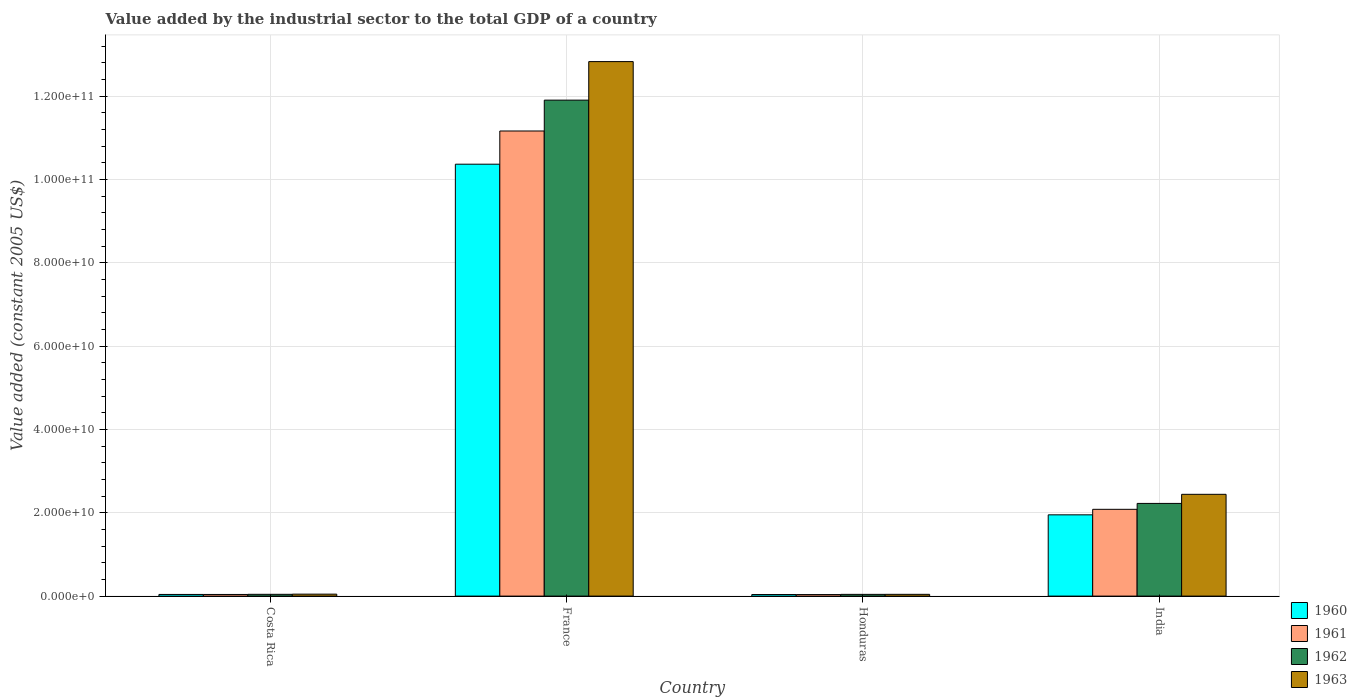How many groups of bars are there?
Provide a short and direct response. 4. Are the number of bars per tick equal to the number of legend labels?
Provide a succinct answer. Yes. How many bars are there on the 3rd tick from the right?
Provide a succinct answer. 4. What is the label of the 3rd group of bars from the left?
Your response must be concise. Honduras. In how many cases, is the number of bars for a given country not equal to the number of legend labels?
Your response must be concise. 0. What is the value added by the industrial sector in 1962 in Costa Rica?
Your answer should be very brief. 4.27e+08. Across all countries, what is the maximum value added by the industrial sector in 1960?
Keep it short and to the point. 1.04e+11. Across all countries, what is the minimum value added by the industrial sector in 1960?
Keep it short and to the point. 3.75e+08. In which country was the value added by the industrial sector in 1961 maximum?
Provide a short and direct response. France. In which country was the value added by the industrial sector in 1962 minimum?
Your response must be concise. Honduras. What is the total value added by the industrial sector in 1960 in the graph?
Ensure brevity in your answer.  1.24e+11. What is the difference between the value added by the industrial sector in 1961 in Costa Rica and that in India?
Offer a terse response. -2.04e+1. What is the difference between the value added by the industrial sector in 1962 in France and the value added by the industrial sector in 1961 in Costa Rica?
Provide a short and direct response. 1.19e+11. What is the average value added by the industrial sector in 1961 per country?
Your response must be concise. 3.33e+1. What is the difference between the value added by the industrial sector of/in 1960 and value added by the industrial sector of/in 1963 in India?
Your response must be concise. -4.92e+09. In how many countries, is the value added by the industrial sector in 1963 greater than 48000000000 US$?
Offer a very short reply. 1. What is the ratio of the value added by the industrial sector in 1962 in France to that in Honduras?
Make the answer very short. 286.26. Is the difference between the value added by the industrial sector in 1960 in Honduras and India greater than the difference between the value added by the industrial sector in 1963 in Honduras and India?
Your response must be concise. Yes. What is the difference between the highest and the second highest value added by the industrial sector in 1962?
Your answer should be compact. 1.19e+11. What is the difference between the highest and the lowest value added by the industrial sector in 1963?
Offer a terse response. 1.28e+11. In how many countries, is the value added by the industrial sector in 1960 greater than the average value added by the industrial sector in 1960 taken over all countries?
Offer a terse response. 1. Is the sum of the value added by the industrial sector in 1960 in Costa Rica and France greater than the maximum value added by the industrial sector in 1963 across all countries?
Provide a short and direct response. No. Is it the case that in every country, the sum of the value added by the industrial sector in 1962 and value added by the industrial sector in 1963 is greater than the sum of value added by the industrial sector in 1961 and value added by the industrial sector in 1960?
Provide a short and direct response. No. What does the 4th bar from the right in India represents?
Make the answer very short. 1960. Is it the case that in every country, the sum of the value added by the industrial sector in 1963 and value added by the industrial sector in 1961 is greater than the value added by the industrial sector in 1960?
Offer a very short reply. Yes. How many bars are there?
Keep it short and to the point. 16. Are all the bars in the graph horizontal?
Your answer should be compact. No. Are the values on the major ticks of Y-axis written in scientific E-notation?
Ensure brevity in your answer.  Yes. Does the graph contain any zero values?
Make the answer very short. No. Where does the legend appear in the graph?
Keep it short and to the point. Bottom right. How many legend labels are there?
Your response must be concise. 4. How are the legend labels stacked?
Your response must be concise. Vertical. What is the title of the graph?
Offer a very short reply. Value added by the industrial sector to the total GDP of a country. What is the label or title of the X-axis?
Your answer should be very brief. Country. What is the label or title of the Y-axis?
Provide a succinct answer. Value added (constant 2005 US$). What is the Value added (constant 2005 US$) in 1960 in Costa Rica?
Ensure brevity in your answer.  3.98e+08. What is the Value added (constant 2005 US$) of 1961 in Costa Rica?
Make the answer very short. 3.94e+08. What is the Value added (constant 2005 US$) of 1962 in Costa Rica?
Your answer should be compact. 4.27e+08. What is the Value added (constant 2005 US$) of 1963 in Costa Rica?
Keep it short and to the point. 4.68e+08. What is the Value added (constant 2005 US$) of 1960 in France?
Provide a succinct answer. 1.04e+11. What is the Value added (constant 2005 US$) of 1961 in France?
Provide a succinct answer. 1.12e+11. What is the Value added (constant 2005 US$) in 1962 in France?
Your response must be concise. 1.19e+11. What is the Value added (constant 2005 US$) of 1963 in France?
Provide a succinct answer. 1.28e+11. What is the Value added (constant 2005 US$) of 1960 in Honduras?
Give a very brief answer. 3.75e+08. What is the Value added (constant 2005 US$) of 1961 in Honduras?
Your answer should be compact. 3.66e+08. What is the Value added (constant 2005 US$) in 1962 in Honduras?
Keep it short and to the point. 4.16e+08. What is the Value added (constant 2005 US$) in 1963 in Honduras?
Keep it short and to the point. 4.23e+08. What is the Value added (constant 2005 US$) in 1960 in India?
Your answer should be compact. 1.95e+1. What is the Value added (constant 2005 US$) in 1961 in India?
Provide a succinct answer. 2.08e+1. What is the Value added (constant 2005 US$) in 1962 in India?
Your response must be concise. 2.22e+1. What is the Value added (constant 2005 US$) in 1963 in India?
Provide a short and direct response. 2.44e+1. Across all countries, what is the maximum Value added (constant 2005 US$) of 1960?
Your answer should be very brief. 1.04e+11. Across all countries, what is the maximum Value added (constant 2005 US$) in 1961?
Keep it short and to the point. 1.12e+11. Across all countries, what is the maximum Value added (constant 2005 US$) in 1962?
Provide a short and direct response. 1.19e+11. Across all countries, what is the maximum Value added (constant 2005 US$) in 1963?
Offer a very short reply. 1.28e+11. Across all countries, what is the minimum Value added (constant 2005 US$) in 1960?
Your answer should be compact. 3.75e+08. Across all countries, what is the minimum Value added (constant 2005 US$) of 1961?
Provide a succinct answer. 3.66e+08. Across all countries, what is the minimum Value added (constant 2005 US$) in 1962?
Make the answer very short. 4.16e+08. Across all countries, what is the minimum Value added (constant 2005 US$) of 1963?
Provide a short and direct response. 4.23e+08. What is the total Value added (constant 2005 US$) of 1960 in the graph?
Provide a succinct answer. 1.24e+11. What is the total Value added (constant 2005 US$) of 1961 in the graph?
Make the answer very short. 1.33e+11. What is the total Value added (constant 2005 US$) in 1962 in the graph?
Offer a very short reply. 1.42e+11. What is the total Value added (constant 2005 US$) of 1963 in the graph?
Give a very brief answer. 1.54e+11. What is the difference between the Value added (constant 2005 US$) of 1960 in Costa Rica and that in France?
Ensure brevity in your answer.  -1.03e+11. What is the difference between the Value added (constant 2005 US$) of 1961 in Costa Rica and that in France?
Your answer should be compact. -1.11e+11. What is the difference between the Value added (constant 2005 US$) in 1962 in Costa Rica and that in France?
Make the answer very short. -1.19e+11. What is the difference between the Value added (constant 2005 US$) in 1963 in Costa Rica and that in France?
Provide a short and direct response. -1.28e+11. What is the difference between the Value added (constant 2005 US$) in 1960 in Costa Rica and that in Honduras?
Ensure brevity in your answer.  2.26e+07. What is the difference between the Value added (constant 2005 US$) of 1961 in Costa Rica and that in Honduras?
Ensure brevity in your answer.  2.78e+07. What is the difference between the Value added (constant 2005 US$) of 1962 in Costa Rica and that in Honduras?
Your answer should be compact. 1.10e+07. What is the difference between the Value added (constant 2005 US$) in 1963 in Costa Rica and that in Honduras?
Offer a very short reply. 4.49e+07. What is the difference between the Value added (constant 2005 US$) of 1960 in Costa Rica and that in India?
Keep it short and to the point. -1.91e+1. What is the difference between the Value added (constant 2005 US$) of 1961 in Costa Rica and that in India?
Your answer should be very brief. -2.04e+1. What is the difference between the Value added (constant 2005 US$) in 1962 in Costa Rica and that in India?
Ensure brevity in your answer.  -2.18e+1. What is the difference between the Value added (constant 2005 US$) of 1963 in Costa Rica and that in India?
Your answer should be compact. -2.40e+1. What is the difference between the Value added (constant 2005 US$) in 1960 in France and that in Honduras?
Make the answer very short. 1.03e+11. What is the difference between the Value added (constant 2005 US$) of 1961 in France and that in Honduras?
Offer a very short reply. 1.11e+11. What is the difference between the Value added (constant 2005 US$) in 1962 in France and that in Honduras?
Provide a short and direct response. 1.19e+11. What is the difference between the Value added (constant 2005 US$) in 1963 in France and that in Honduras?
Your answer should be compact. 1.28e+11. What is the difference between the Value added (constant 2005 US$) of 1960 in France and that in India?
Provide a succinct answer. 8.42e+1. What is the difference between the Value added (constant 2005 US$) of 1961 in France and that in India?
Your response must be concise. 9.08e+1. What is the difference between the Value added (constant 2005 US$) in 1962 in France and that in India?
Your answer should be compact. 9.68e+1. What is the difference between the Value added (constant 2005 US$) of 1963 in France and that in India?
Provide a short and direct response. 1.04e+11. What is the difference between the Value added (constant 2005 US$) of 1960 in Honduras and that in India?
Offer a very short reply. -1.91e+1. What is the difference between the Value added (constant 2005 US$) of 1961 in Honduras and that in India?
Offer a terse response. -2.05e+1. What is the difference between the Value added (constant 2005 US$) in 1962 in Honduras and that in India?
Offer a terse response. -2.18e+1. What is the difference between the Value added (constant 2005 US$) of 1963 in Honduras and that in India?
Ensure brevity in your answer.  -2.40e+1. What is the difference between the Value added (constant 2005 US$) in 1960 in Costa Rica and the Value added (constant 2005 US$) in 1961 in France?
Ensure brevity in your answer.  -1.11e+11. What is the difference between the Value added (constant 2005 US$) of 1960 in Costa Rica and the Value added (constant 2005 US$) of 1962 in France?
Provide a succinct answer. -1.19e+11. What is the difference between the Value added (constant 2005 US$) in 1960 in Costa Rica and the Value added (constant 2005 US$) in 1963 in France?
Your answer should be very brief. -1.28e+11. What is the difference between the Value added (constant 2005 US$) in 1961 in Costa Rica and the Value added (constant 2005 US$) in 1962 in France?
Offer a terse response. -1.19e+11. What is the difference between the Value added (constant 2005 US$) in 1961 in Costa Rica and the Value added (constant 2005 US$) in 1963 in France?
Your answer should be compact. -1.28e+11. What is the difference between the Value added (constant 2005 US$) in 1962 in Costa Rica and the Value added (constant 2005 US$) in 1963 in France?
Your response must be concise. -1.28e+11. What is the difference between the Value added (constant 2005 US$) in 1960 in Costa Rica and the Value added (constant 2005 US$) in 1961 in Honduras?
Your answer should be very brief. 3.20e+07. What is the difference between the Value added (constant 2005 US$) in 1960 in Costa Rica and the Value added (constant 2005 US$) in 1962 in Honduras?
Offer a terse response. -1.81e+07. What is the difference between the Value added (constant 2005 US$) in 1960 in Costa Rica and the Value added (constant 2005 US$) in 1963 in Honduras?
Make the answer very short. -2.52e+07. What is the difference between the Value added (constant 2005 US$) in 1961 in Costa Rica and the Value added (constant 2005 US$) in 1962 in Honduras?
Make the answer very short. -2.22e+07. What is the difference between the Value added (constant 2005 US$) of 1961 in Costa Rica and the Value added (constant 2005 US$) of 1963 in Honduras?
Give a very brief answer. -2.94e+07. What is the difference between the Value added (constant 2005 US$) in 1962 in Costa Rica and the Value added (constant 2005 US$) in 1963 in Honduras?
Provide a succinct answer. 3.81e+06. What is the difference between the Value added (constant 2005 US$) of 1960 in Costa Rica and the Value added (constant 2005 US$) of 1961 in India?
Keep it short and to the point. -2.04e+1. What is the difference between the Value added (constant 2005 US$) of 1960 in Costa Rica and the Value added (constant 2005 US$) of 1962 in India?
Keep it short and to the point. -2.18e+1. What is the difference between the Value added (constant 2005 US$) of 1960 in Costa Rica and the Value added (constant 2005 US$) of 1963 in India?
Your answer should be compact. -2.40e+1. What is the difference between the Value added (constant 2005 US$) of 1961 in Costa Rica and the Value added (constant 2005 US$) of 1962 in India?
Offer a very short reply. -2.19e+1. What is the difference between the Value added (constant 2005 US$) in 1961 in Costa Rica and the Value added (constant 2005 US$) in 1963 in India?
Give a very brief answer. -2.40e+1. What is the difference between the Value added (constant 2005 US$) in 1962 in Costa Rica and the Value added (constant 2005 US$) in 1963 in India?
Give a very brief answer. -2.40e+1. What is the difference between the Value added (constant 2005 US$) in 1960 in France and the Value added (constant 2005 US$) in 1961 in Honduras?
Your answer should be compact. 1.03e+11. What is the difference between the Value added (constant 2005 US$) in 1960 in France and the Value added (constant 2005 US$) in 1962 in Honduras?
Your answer should be very brief. 1.03e+11. What is the difference between the Value added (constant 2005 US$) in 1960 in France and the Value added (constant 2005 US$) in 1963 in Honduras?
Make the answer very short. 1.03e+11. What is the difference between the Value added (constant 2005 US$) of 1961 in France and the Value added (constant 2005 US$) of 1962 in Honduras?
Offer a terse response. 1.11e+11. What is the difference between the Value added (constant 2005 US$) in 1961 in France and the Value added (constant 2005 US$) in 1963 in Honduras?
Offer a terse response. 1.11e+11. What is the difference between the Value added (constant 2005 US$) in 1962 in France and the Value added (constant 2005 US$) in 1963 in Honduras?
Offer a terse response. 1.19e+11. What is the difference between the Value added (constant 2005 US$) in 1960 in France and the Value added (constant 2005 US$) in 1961 in India?
Provide a succinct answer. 8.28e+1. What is the difference between the Value added (constant 2005 US$) in 1960 in France and the Value added (constant 2005 US$) in 1962 in India?
Provide a short and direct response. 8.14e+1. What is the difference between the Value added (constant 2005 US$) in 1960 in France and the Value added (constant 2005 US$) in 1963 in India?
Offer a terse response. 7.92e+1. What is the difference between the Value added (constant 2005 US$) in 1961 in France and the Value added (constant 2005 US$) in 1962 in India?
Offer a terse response. 8.94e+1. What is the difference between the Value added (constant 2005 US$) in 1961 in France and the Value added (constant 2005 US$) in 1963 in India?
Offer a terse response. 8.72e+1. What is the difference between the Value added (constant 2005 US$) of 1962 in France and the Value added (constant 2005 US$) of 1963 in India?
Your response must be concise. 9.46e+1. What is the difference between the Value added (constant 2005 US$) in 1960 in Honduras and the Value added (constant 2005 US$) in 1961 in India?
Provide a short and direct response. -2.05e+1. What is the difference between the Value added (constant 2005 US$) of 1960 in Honduras and the Value added (constant 2005 US$) of 1962 in India?
Your answer should be compact. -2.19e+1. What is the difference between the Value added (constant 2005 US$) in 1960 in Honduras and the Value added (constant 2005 US$) in 1963 in India?
Your response must be concise. -2.41e+1. What is the difference between the Value added (constant 2005 US$) of 1961 in Honduras and the Value added (constant 2005 US$) of 1962 in India?
Provide a succinct answer. -2.19e+1. What is the difference between the Value added (constant 2005 US$) in 1961 in Honduras and the Value added (constant 2005 US$) in 1963 in India?
Keep it short and to the point. -2.41e+1. What is the difference between the Value added (constant 2005 US$) in 1962 in Honduras and the Value added (constant 2005 US$) in 1963 in India?
Your answer should be compact. -2.40e+1. What is the average Value added (constant 2005 US$) in 1960 per country?
Offer a terse response. 3.10e+1. What is the average Value added (constant 2005 US$) in 1961 per country?
Your answer should be compact. 3.33e+1. What is the average Value added (constant 2005 US$) in 1962 per country?
Offer a very short reply. 3.55e+1. What is the average Value added (constant 2005 US$) in 1963 per country?
Keep it short and to the point. 3.84e+1. What is the difference between the Value added (constant 2005 US$) of 1960 and Value added (constant 2005 US$) of 1961 in Costa Rica?
Offer a very short reply. 4.19e+06. What is the difference between the Value added (constant 2005 US$) in 1960 and Value added (constant 2005 US$) in 1962 in Costa Rica?
Provide a short and direct response. -2.91e+07. What is the difference between the Value added (constant 2005 US$) in 1960 and Value added (constant 2005 US$) in 1963 in Costa Rica?
Your answer should be very brief. -7.01e+07. What is the difference between the Value added (constant 2005 US$) in 1961 and Value added (constant 2005 US$) in 1962 in Costa Rica?
Ensure brevity in your answer.  -3.32e+07. What is the difference between the Value added (constant 2005 US$) in 1961 and Value added (constant 2005 US$) in 1963 in Costa Rica?
Offer a terse response. -7.43e+07. What is the difference between the Value added (constant 2005 US$) of 1962 and Value added (constant 2005 US$) of 1963 in Costa Rica?
Ensure brevity in your answer.  -4.11e+07. What is the difference between the Value added (constant 2005 US$) in 1960 and Value added (constant 2005 US$) in 1961 in France?
Offer a terse response. -7.97e+09. What is the difference between the Value added (constant 2005 US$) in 1960 and Value added (constant 2005 US$) in 1962 in France?
Your answer should be very brief. -1.54e+1. What is the difference between the Value added (constant 2005 US$) in 1960 and Value added (constant 2005 US$) in 1963 in France?
Provide a succinct answer. -2.46e+1. What is the difference between the Value added (constant 2005 US$) of 1961 and Value added (constant 2005 US$) of 1962 in France?
Offer a very short reply. -7.41e+09. What is the difference between the Value added (constant 2005 US$) of 1961 and Value added (constant 2005 US$) of 1963 in France?
Ensure brevity in your answer.  -1.67e+1. What is the difference between the Value added (constant 2005 US$) of 1962 and Value added (constant 2005 US$) of 1963 in France?
Your answer should be very brief. -9.25e+09. What is the difference between the Value added (constant 2005 US$) of 1960 and Value added (constant 2005 US$) of 1961 in Honduras?
Your answer should be compact. 9.37e+06. What is the difference between the Value added (constant 2005 US$) in 1960 and Value added (constant 2005 US$) in 1962 in Honduras?
Provide a short and direct response. -4.07e+07. What is the difference between the Value added (constant 2005 US$) of 1960 and Value added (constant 2005 US$) of 1963 in Honduras?
Offer a very short reply. -4.79e+07. What is the difference between the Value added (constant 2005 US$) in 1961 and Value added (constant 2005 US$) in 1962 in Honduras?
Provide a short and direct response. -5.00e+07. What is the difference between the Value added (constant 2005 US$) in 1961 and Value added (constant 2005 US$) in 1963 in Honduras?
Ensure brevity in your answer.  -5.72e+07. What is the difference between the Value added (constant 2005 US$) of 1962 and Value added (constant 2005 US$) of 1963 in Honduras?
Give a very brief answer. -7.19e+06. What is the difference between the Value added (constant 2005 US$) of 1960 and Value added (constant 2005 US$) of 1961 in India?
Ensure brevity in your answer.  -1.32e+09. What is the difference between the Value added (constant 2005 US$) in 1960 and Value added (constant 2005 US$) in 1962 in India?
Make the answer very short. -2.74e+09. What is the difference between the Value added (constant 2005 US$) in 1960 and Value added (constant 2005 US$) in 1963 in India?
Offer a very short reply. -4.92e+09. What is the difference between the Value added (constant 2005 US$) in 1961 and Value added (constant 2005 US$) in 1962 in India?
Make the answer very short. -1.42e+09. What is the difference between the Value added (constant 2005 US$) in 1961 and Value added (constant 2005 US$) in 1963 in India?
Provide a succinct answer. -3.60e+09. What is the difference between the Value added (constant 2005 US$) in 1962 and Value added (constant 2005 US$) in 1963 in India?
Offer a terse response. -2.18e+09. What is the ratio of the Value added (constant 2005 US$) in 1960 in Costa Rica to that in France?
Keep it short and to the point. 0. What is the ratio of the Value added (constant 2005 US$) of 1961 in Costa Rica to that in France?
Provide a succinct answer. 0. What is the ratio of the Value added (constant 2005 US$) in 1962 in Costa Rica to that in France?
Provide a succinct answer. 0. What is the ratio of the Value added (constant 2005 US$) of 1963 in Costa Rica to that in France?
Ensure brevity in your answer.  0. What is the ratio of the Value added (constant 2005 US$) of 1960 in Costa Rica to that in Honduras?
Make the answer very short. 1.06. What is the ratio of the Value added (constant 2005 US$) in 1961 in Costa Rica to that in Honduras?
Give a very brief answer. 1.08. What is the ratio of the Value added (constant 2005 US$) in 1962 in Costa Rica to that in Honduras?
Ensure brevity in your answer.  1.03. What is the ratio of the Value added (constant 2005 US$) of 1963 in Costa Rica to that in Honduras?
Your response must be concise. 1.11. What is the ratio of the Value added (constant 2005 US$) of 1960 in Costa Rica to that in India?
Ensure brevity in your answer.  0.02. What is the ratio of the Value added (constant 2005 US$) in 1961 in Costa Rica to that in India?
Your answer should be very brief. 0.02. What is the ratio of the Value added (constant 2005 US$) of 1962 in Costa Rica to that in India?
Your answer should be very brief. 0.02. What is the ratio of the Value added (constant 2005 US$) in 1963 in Costa Rica to that in India?
Make the answer very short. 0.02. What is the ratio of the Value added (constant 2005 US$) in 1960 in France to that in Honduras?
Ensure brevity in your answer.  276.31. What is the ratio of the Value added (constant 2005 US$) of 1961 in France to that in Honduras?
Your response must be concise. 305.16. What is the ratio of the Value added (constant 2005 US$) of 1962 in France to that in Honduras?
Offer a terse response. 286.26. What is the ratio of the Value added (constant 2005 US$) of 1963 in France to that in Honduras?
Provide a succinct answer. 303.25. What is the ratio of the Value added (constant 2005 US$) in 1960 in France to that in India?
Give a very brief answer. 5.32. What is the ratio of the Value added (constant 2005 US$) in 1961 in France to that in India?
Your answer should be very brief. 5.36. What is the ratio of the Value added (constant 2005 US$) in 1962 in France to that in India?
Offer a very short reply. 5.35. What is the ratio of the Value added (constant 2005 US$) of 1963 in France to that in India?
Keep it short and to the point. 5.25. What is the ratio of the Value added (constant 2005 US$) of 1960 in Honduras to that in India?
Your answer should be compact. 0.02. What is the ratio of the Value added (constant 2005 US$) in 1961 in Honduras to that in India?
Provide a succinct answer. 0.02. What is the ratio of the Value added (constant 2005 US$) in 1962 in Honduras to that in India?
Offer a very short reply. 0.02. What is the ratio of the Value added (constant 2005 US$) of 1963 in Honduras to that in India?
Your answer should be compact. 0.02. What is the difference between the highest and the second highest Value added (constant 2005 US$) of 1960?
Offer a very short reply. 8.42e+1. What is the difference between the highest and the second highest Value added (constant 2005 US$) of 1961?
Your answer should be very brief. 9.08e+1. What is the difference between the highest and the second highest Value added (constant 2005 US$) in 1962?
Your answer should be compact. 9.68e+1. What is the difference between the highest and the second highest Value added (constant 2005 US$) of 1963?
Make the answer very short. 1.04e+11. What is the difference between the highest and the lowest Value added (constant 2005 US$) of 1960?
Your answer should be compact. 1.03e+11. What is the difference between the highest and the lowest Value added (constant 2005 US$) of 1961?
Provide a short and direct response. 1.11e+11. What is the difference between the highest and the lowest Value added (constant 2005 US$) of 1962?
Your answer should be compact. 1.19e+11. What is the difference between the highest and the lowest Value added (constant 2005 US$) in 1963?
Your answer should be compact. 1.28e+11. 